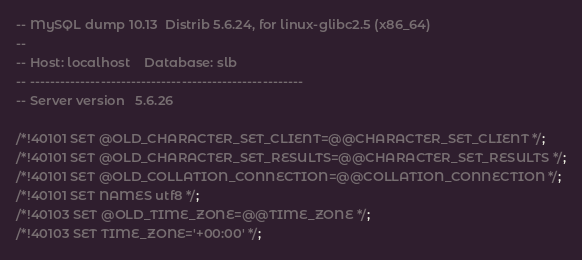Convert code to text. <code><loc_0><loc_0><loc_500><loc_500><_SQL_>-- MySQL dump 10.13  Distrib 5.6.24, for linux-glibc2.5 (x86_64)
--
-- Host: localhost    Database: slb
-- ------------------------------------------------------
-- Server version	5.6.26

/*!40101 SET @OLD_CHARACTER_SET_CLIENT=@@CHARACTER_SET_CLIENT */;
/*!40101 SET @OLD_CHARACTER_SET_RESULTS=@@CHARACTER_SET_RESULTS */;
/*!40101 SET @OLD_COLLATION_CONNECTION=@@COLLATION_CONNECTION */;
/*!40101 SET NAMES utf8 */;
/*!40103 SET @OLD_TIME_ZONE=@@TIME_ZONE */;
/*!40103 SET TIME_ZONE='+00:00' */;</code> 